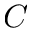<formula> <loc_0><loc_0><loc_500><loc_500>C</formula> 